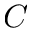<formula> <loc_0><loc_0><loc_500><loc_500>C</formula> 